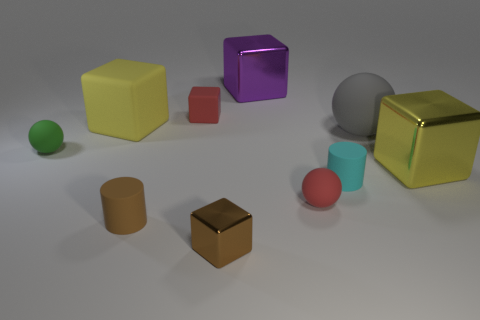Subtract all small red spheres. How many spheres are left? 2 Subtract 1 blocks. How many blocks are left? 4 Subtract all spheres. How many objects are left? 7 Subtract all brown cylinders. How many yellow cubes are left? 2 Subtract 1 purple blocks. How many objects are left? 9 Subtract all yellow spheres. Subtract all blue cylinders. How many spheres are left? 3 Subtract all cylinders. Subtract all yellow rubber cubes. How many objects are left? 7 Add 2 yellow objects. How many yellow objects are left? 4 Add 4 cyan matte cylinders. How many cyan matte cylinders exist? 5 Subtract all brown cylinders. How many cylinders are left? 1 